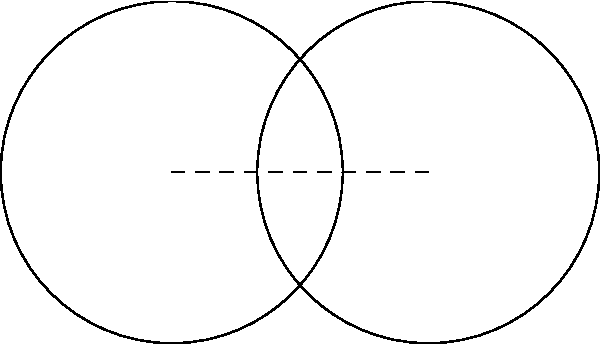In a game of billiards, two balls with a radius of 2.86 cm are touching each other. The distance between their centers is 4.29 cm. Calculate the area of the lens-shaped region formed by the intersection of these two balls, rounded to the nearest square centimeter. Let's approach this step-by-step:

1) First, we need to find the height (h) of the circular segment. We can do this using the Pythagorean theorem:

   $$(2.86)^2 = (4.29/2)^2 + (2.86 - h)^2$$

2) Simplifying:
   
   $$8.1796 = 4.600225 + (2.86 - h)^2$$
   $$(2.86 - h)^2 = 3.579375$$
   $$2.86 - h = \sqrt{3.579375} = 1.8919$$
   $$h = 2.86 - 1.8919 = 0.9681 \text{ cm}$$

3) Now we can calculate the area of one circular segment using the formula:
   
   $$A_{segment} = r^2 \arccos(\frac{r-h}{r}) - (r-h)\sqrt{2rh-h^2}$$

4) Plugging in our values:
   
   $$A_{segment} = (2.86)^2 \arccos(\frac{2.86-0.9681}{2.86}) - (2.86-0.9681)\sqrt{2(2.86)(0.9681)-(0.9681)^2}$$

5) This simplifies to:
   
   $$A_{segment} = 8.1796 \arccos(0.6615) - 1.8919\sqrt{5.5359-0.9372}$$
   $$A_{segment} = 8.1796(0.8511) - 1.8919(2.2361)$$
   $$A_{segment} = 6.9616 - 4.2304 = 2.7312 \text{ cm}^2$$

6) The total area of the lens is twice this:
   
   $$A_{lens} = 2(2.7312) = 5.4624 \text{ cm}^2$$

7) Rounding to the nearest square centimeter:
   
   $$A_{lens} \approx 5 \text{ cm}^2$$
Answer: 5 cm² 